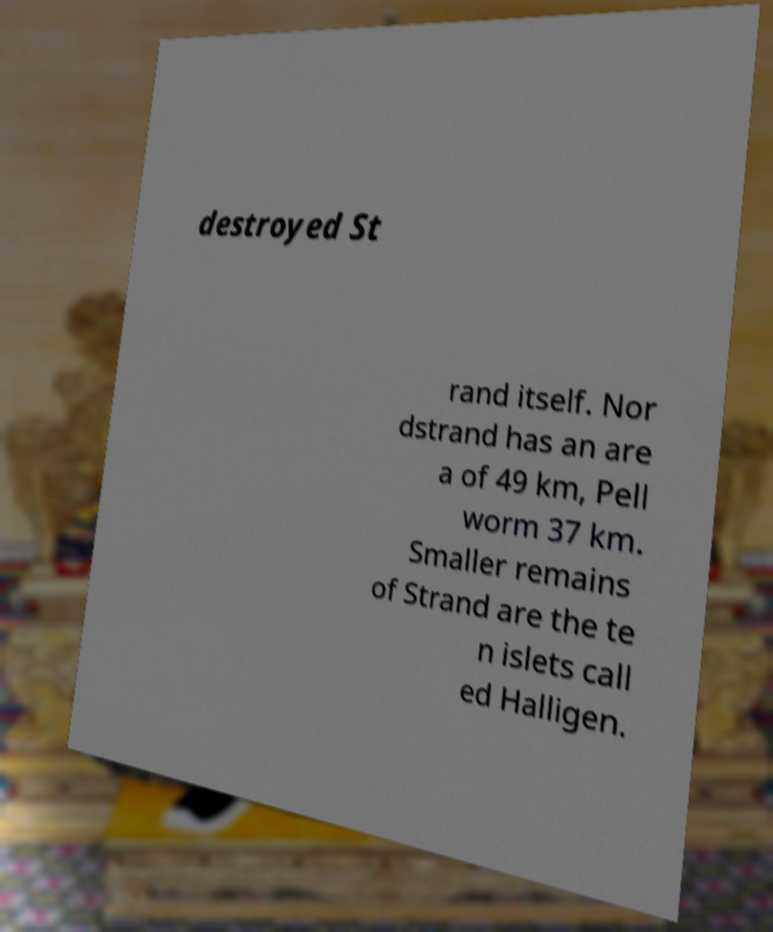Could you extract and type out the text from this image? destroyed St rand itself. Nor dstrand has an are a of 49 km, Pell worm 37 km. Smaller remains of Strand are the te n islets call ed Halligen. 